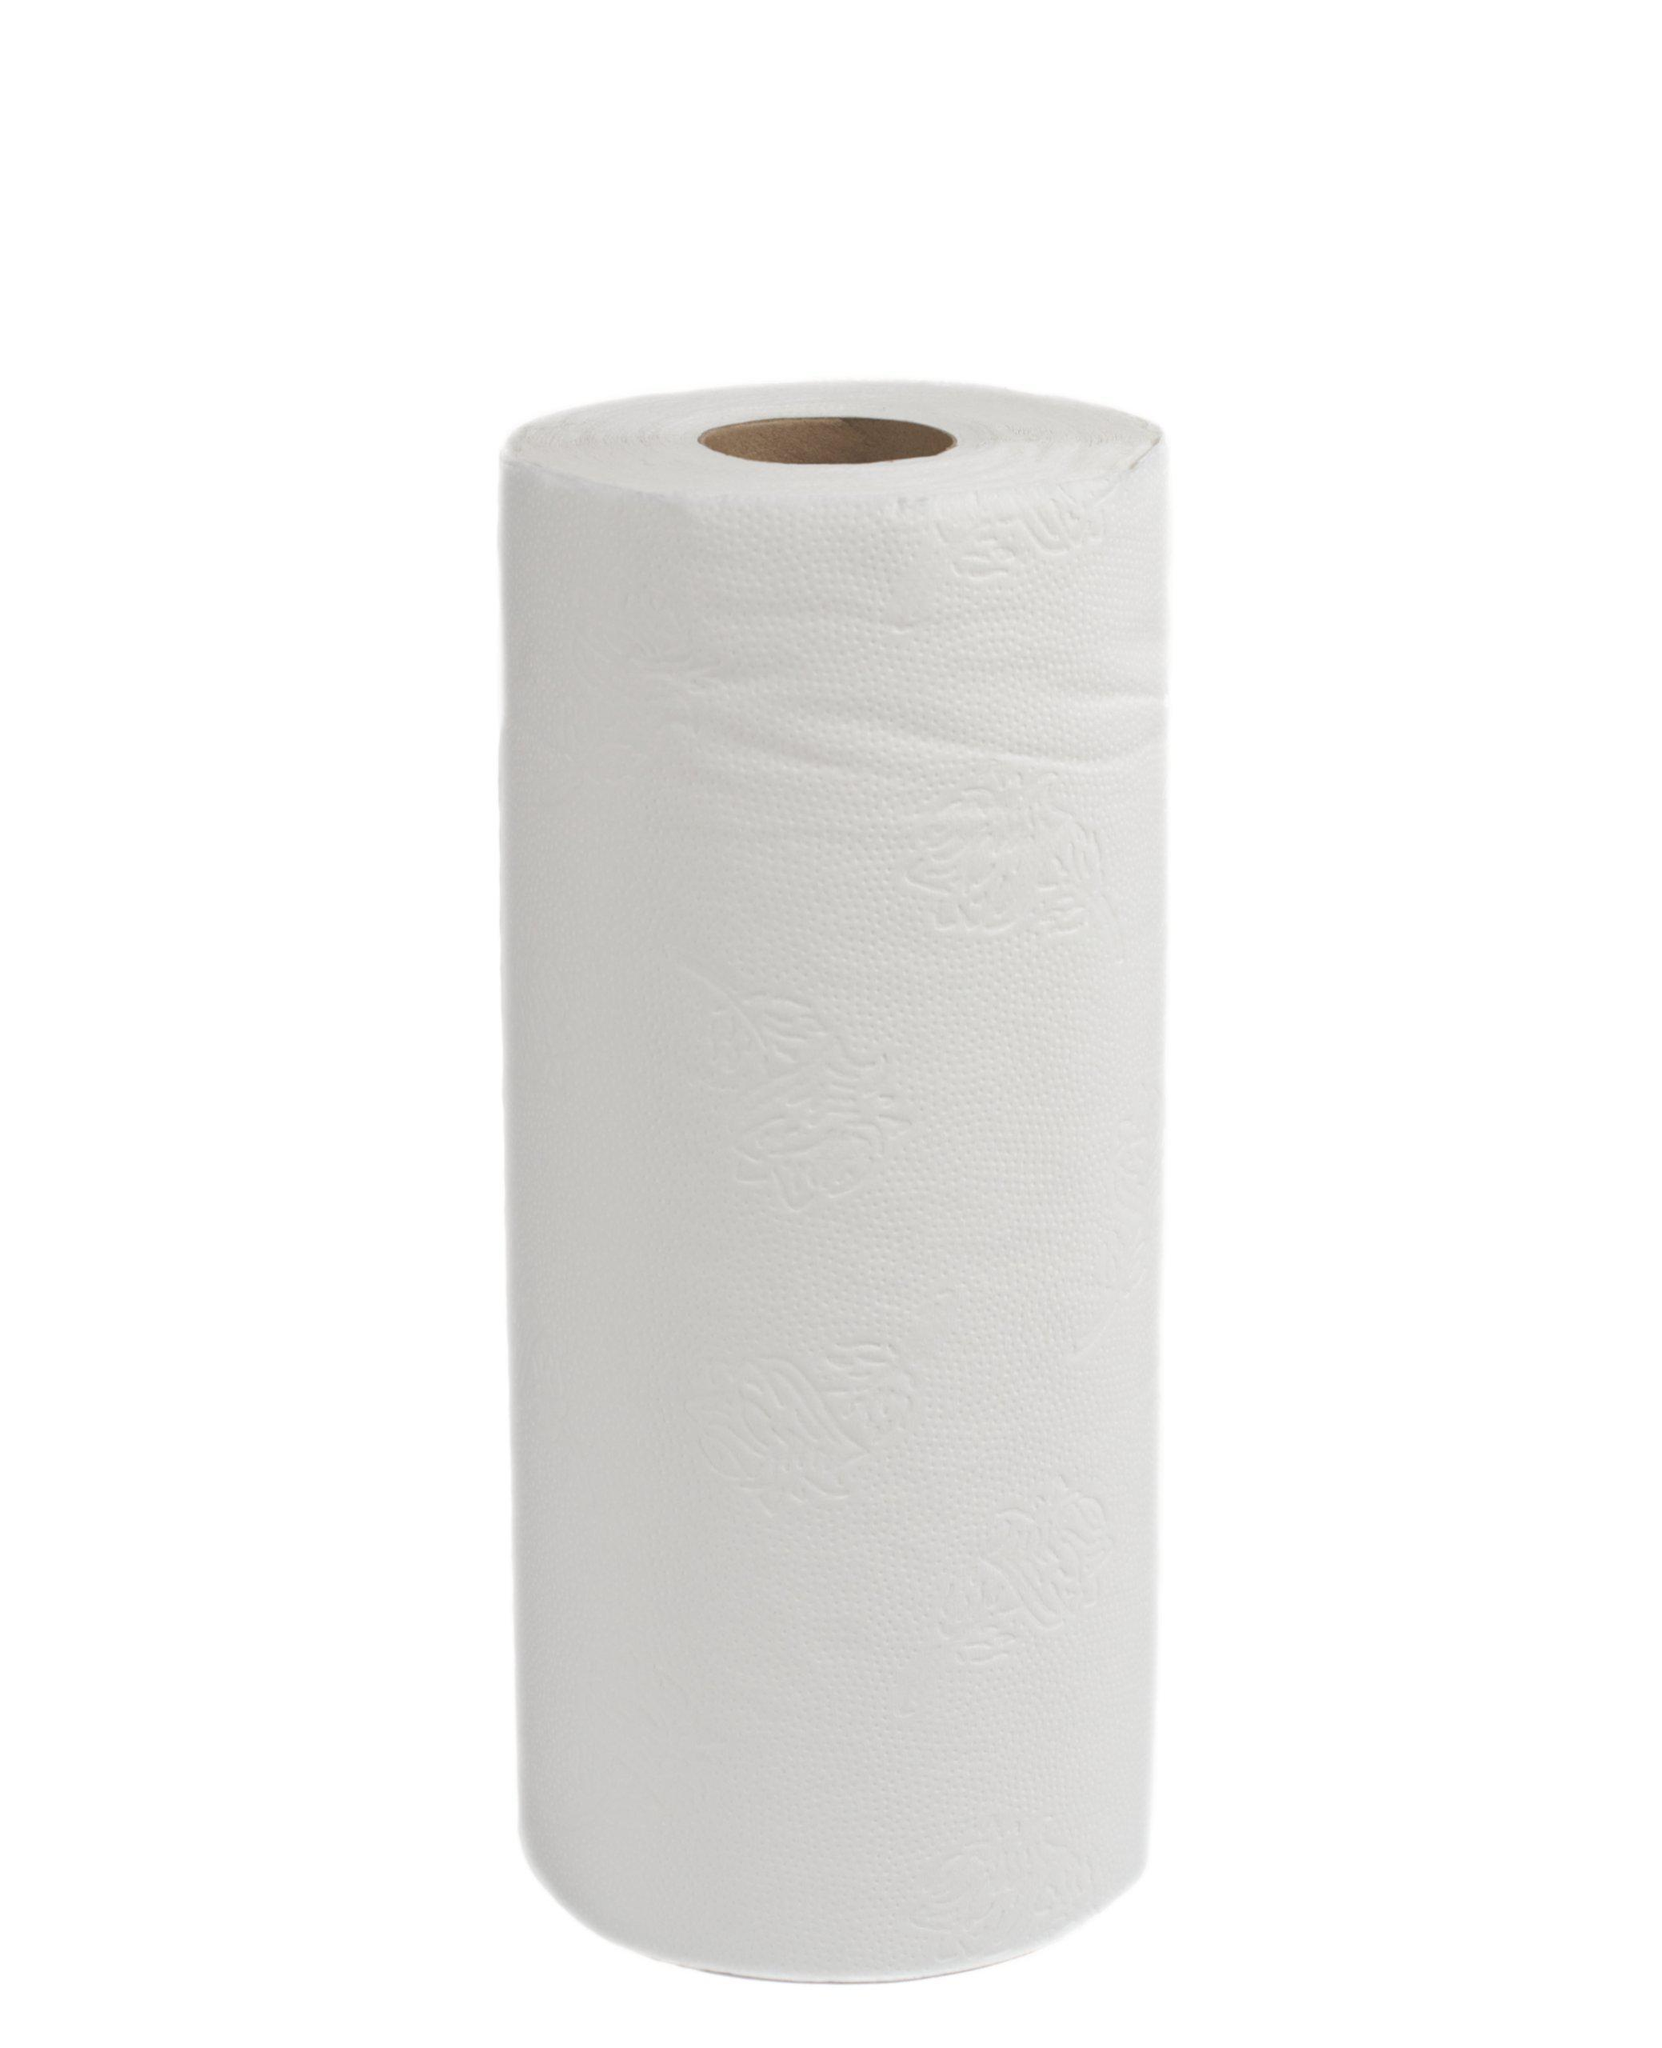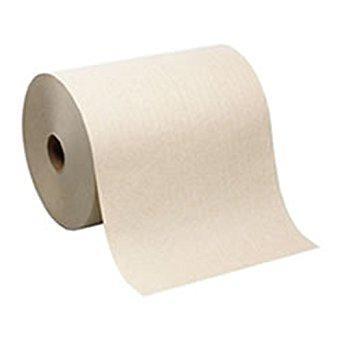The first image is the image on the left, the second image is the image on the right. Examine the images to the left and right. Is the description "One of the images features a white, upright roll of paper towels" accurate? Answer yes or no. Yes. The first image is the image on the left, the second image is the image on the right. Given the left and right images, does the statement "There is a brown roll of paper towels in the image on the right." hold true? Answer yes or no. Yes. The first image is the image on the left, the second image is the image on the right. Analyze the images presented: Is the assertion "one of the images contains two stacks of paper towels." valid? Answer yes or no. No. The first image is the image on the left, the second image is the image on the right. Assess this claim about the two images: "there is exactly one standing roll of paper towels in the image on the left". Correct or not? Answer yes or no. Yes. The first image is the image on the left, the second image is the image on the right. Given the left and right images, does the statement "One of the images shows folded paper towels." hold true? Answer yes or no. No. 